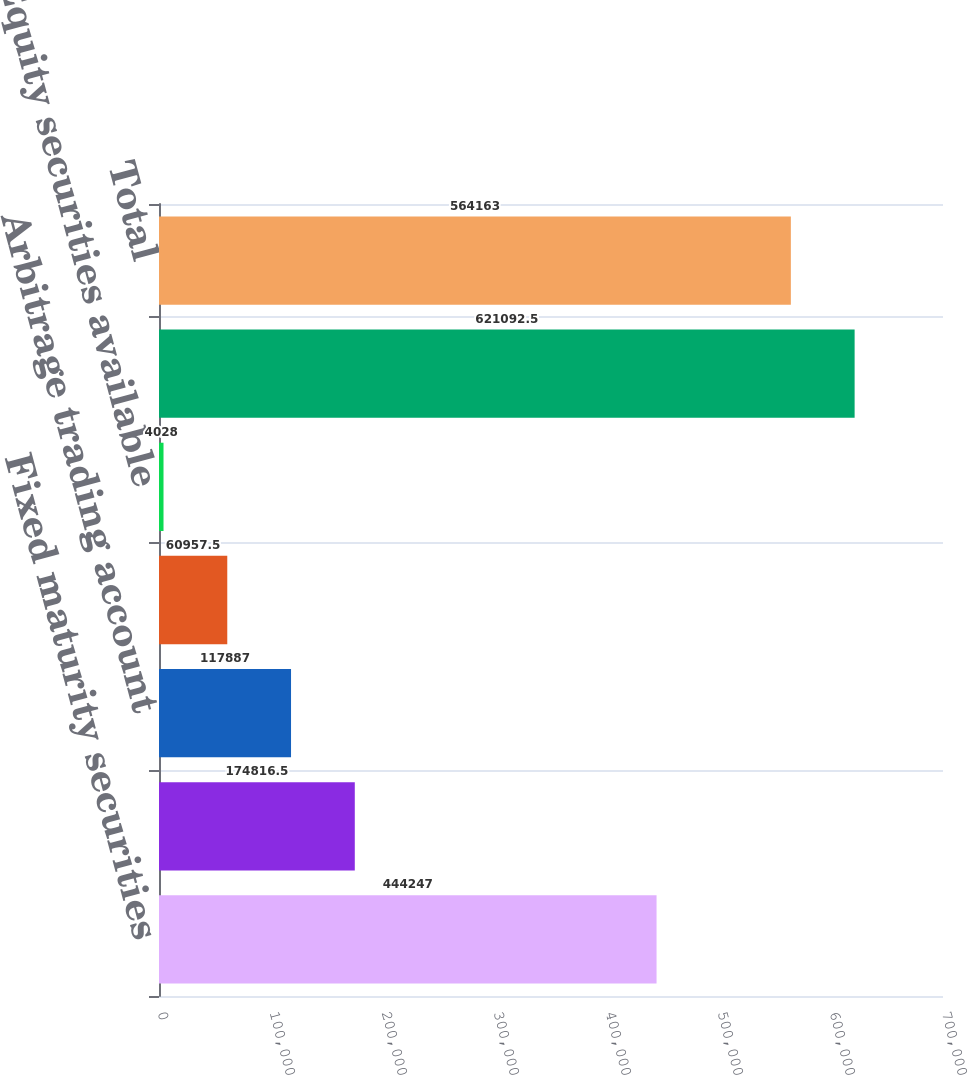Convert chart to OTSL. <chart><loc_0><loc_0><loc_500><loc_500><bar_chart><fcel>Fixed maturity securities<fcel>Investment funds<fcel>Arbitrage trading account<fcel>Real estate<fcel>Equity securities available<fcel>Gross investment income<fcel>Total<nl><fcel>444247<fcel>174816<fcel>117887<fcel>60957.5<fcel>4028<fcel>621092<fcel>564163<nl></chart> 